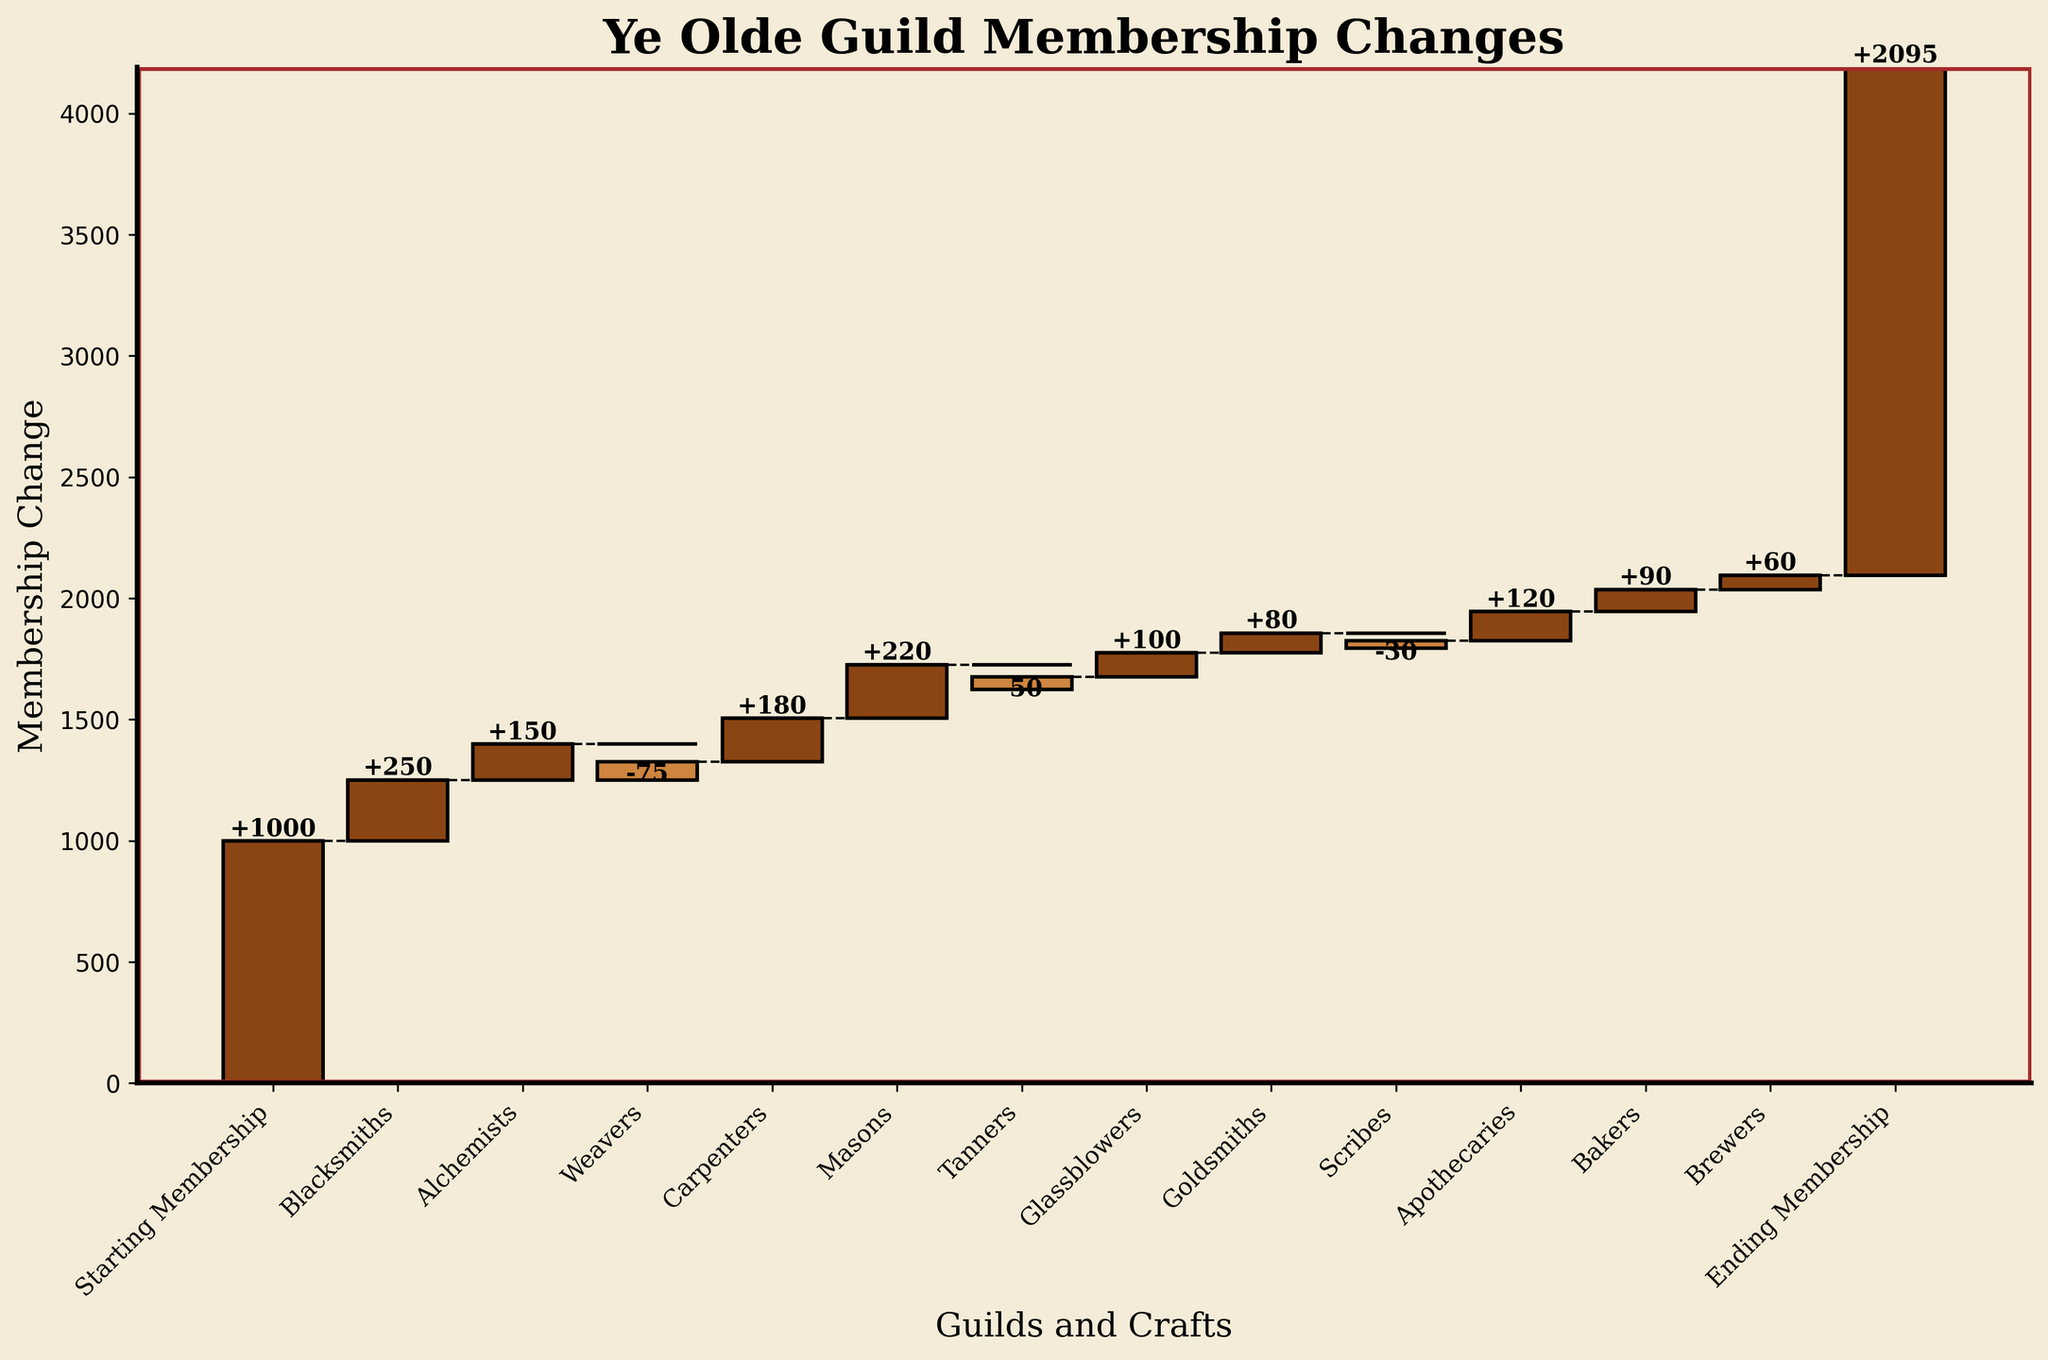What is the initial membership of the guilds? The first bar represents the starting membership, labeled "Starting Membership," which is 1000 members.
Answer: 1000 What is the final membership count of all guilds combined? The last bar in the chart represents the ending membership, labeled "Ending Membership," which is 2095 members.
Answer: 2095 Which craft contributed the highest increase in membership? The bar that represents the greatest positive change belongs to the Masons, with a change of +220 members.
Answer: Masons Which craft saw the highest decrease in membership? The Weavers bar shows the largest negative change with -75 members.
Answer: Weavers What is the combined increase in membership from Blacksmiths, Alchemists, and Carpenters? Blacksmiths, Alchemists, and Carpenters have changes of +250, +150, and +180, respectively. Summing them: 250 + 150 + 180 = 580.
Answer: 580 If you exclude the negative changes, what would the final membership be? Sum all positive changes: 1000 (initial) + 250 (Blacksmiths) + 150 (Alchemists) + 180 (Carpenters) + 220 (Masons) + 100 (Glassblowers) + 80 (Goldsmiths) + 120 (Apothecaries) + 90 (Bakers) + 60 (Brewers) = 2250. Excluding negative changes, the result remains unchanged because we don't subtract anything.
Answer: 2250 Between which two crafts is the smallest membership change observed? Scribes and Tanners both show negative changes, but Tanners with -50 and Scribes with -30 have the closest changes in magnitude, with a difference of just 20 members.
Answer: Scribes and Tanners How many crafts experienced a decrease in membership? By examining the negative bars, there are four crafts with decreases: Weavers, Tanners, Scribes, and one other that can be counted visually.
Answer: 4 What was the total membership increase due to all crafts before accounting for losses? Total all the positive changes: 250 (Blacksmiths) + 150 (Alchemists) + 180 (Carpenters) + 220 (Masons) + 100 (Glassblowers) + 80 (Goldsmiths) + 120 (Apothecaries) + 90 (Bakers) + 60 (Brewers) = 1250.
Answer: 1250 Which craft has the smallest positive change? Among the positive changes, the smallest one belongs to the Brewers with +60.
Answer: Brewers 